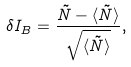<formula> <loc_0><loc_0><loc_500><loc_500>\delta I _ { B } = \frac { \tilde { N } - \langle \tilde { N } \rangle } { \sqrt { \langle \tilde { N } \rangle } } ,</formula> 